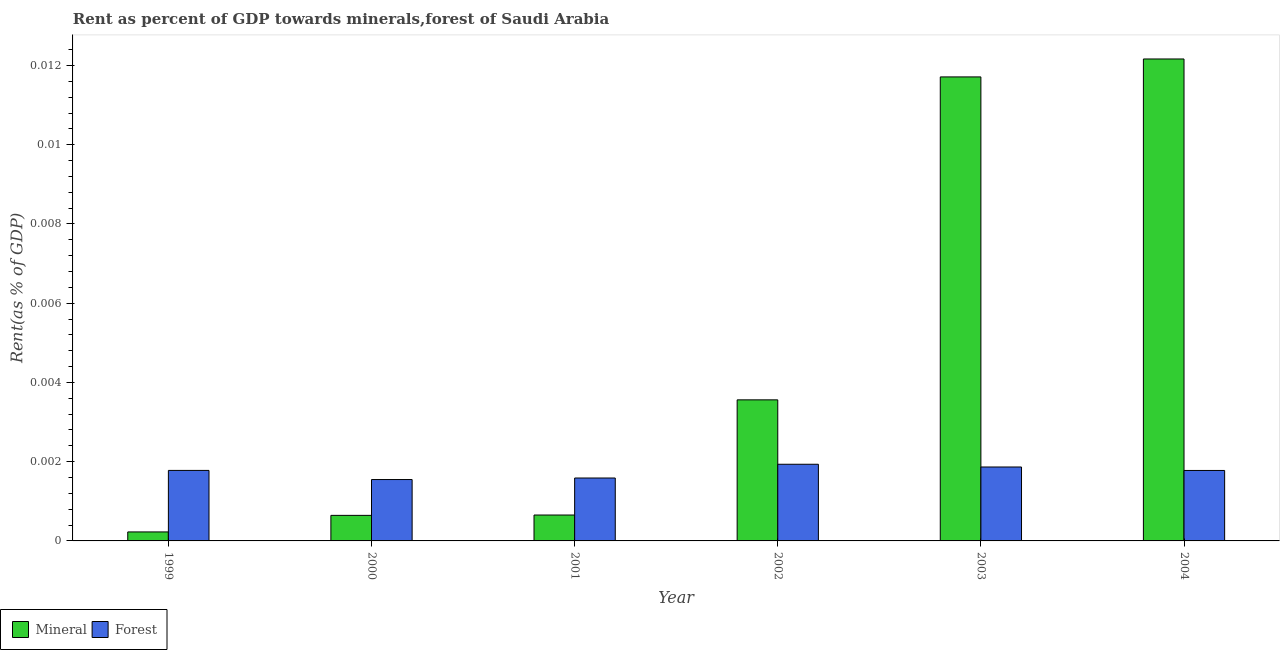How many groups of bars are there?
Provide a short and direct response. 6. Are the number of bars per tick equal to the number of legend labels?
Your response must be concise. Yes. Are the number of bars on each tick of the X-axis equal?
Give a very brief answer. Yes. How many bars are there on the 5th tick from the left?
Your answer should be compact. 2. What is the label of the 1st group of bars from the left?
Make the answer very short. 1999. What is the mineral rent in 2002?
Offer a very short reply. 0. Across all years, what is the maximum mineral rent?
Your answer should be very brief. 0.01. Across all years, what is the minimum forest rent?
Offer a terse response. 0. In which year was the mineral rent minimum?
Keep it short and to the point. 1999. What is the total forest rent in the graph?
Your answer should be very brief. 0.01. What is the difference between the mineral rent in 2002 and that in 2003?
Offer a very short reply. -0.01. What is the difference between the forest rent in 2001 and the mineral rent in 1999?
Provide a succinct answer. -0. What is the average forest rent per year?
Offer a terse response. 0. In the year 2003, what is the difference between the forest rent and mineral rent?
Make the answer very short. 0. What is the ratio of the mineral rent in 1999 to that in 2004?
Provide a succinct answer. 0.02. Is the mineral rent in 2002 less than that in 2004?
Your response must be concise. Yes. Is the difference between the mineral rent in 2000 and 2004 greater than the difference between the forest rent in 2000 and 2004?
Your answer should be very brief. No. What is the difference between the highest and the second highest mineral rent?
Your response must be concise. 0. What is the difference between the highest and the lowest forest rent?
Offer a terse response. 0. In how many years, is the mineral rent greater than the average mineral rent taken over all years?
Your answer should be compact. 2. Is the sum of the forest rent in 2002 and 2003 greater than the maximum mineral rent across all years?
Your answer should be compact. Yes. What does the 2nd bar from the left in 2001 represents?
Your answer should be very brief. Forest. What does the 2nd bar from the right in 2004 represents?
Offer a terse response. Mineral. How many years are there in the graph?
Offer a terse response. 6. What is the difference between two consecutive major ticks on the Y-axis?
Offer a terse response. 0. How many legend labels are there?
Offer a terse response. 2. What is the title of the graph?
Offer a terse response. Rent as percent of GDP towards minerals,forest of Saudi Arabia. What is the label or title of the X-axis?
Make the answer very short. Year. What is the label or title of the Y-axis?
Offer a terse response. Rent(as % of GDP). What is the Rent(as % of GDP) of Mineral in 1999?
Your answer should be very brief. 0. What is the Rent(as % of GDP) in Forest in 1999?
Ensure brevity in your answer.  0. What is the Rent(as % of GDP) in Mineral in 2000?
Offer a terse response. 0. What is the Rent(as % of GDP) in Forest in 2000?
Give a very brief answer. 0. What is the Rent(as % of GDP) of Mineral in 2001?
Offer a very short reply. 0. What is the Rent(as % of GDP) of Forest in 2001?
Your answer should be very brief. 0. What is the Rent(as % of GDP) in Mineral in 2002?
Offer a terse response. 0. What is the Rent(as % of GDP) of Forest in 2002?
Offer a very short reply. 0. What is the Rent(as % of GDP) of Mineral in 2003?
Provide a short and direct response. 0.01. What is the Rent(as % of GDP) of Forest in 2003?
Offer a terse response. 0. What is the Rent(as % of GDP) of Mineral in 2004?
Keep it short and to the point. 0.01. What is the Rent(as % of GDP) of Forest in 2004?
Offer a very short reply. 0. Across all years, what is the maximum Rent(as % of GDP) of Mineral?
Offer a very short reply. 0.01. Across all years, what is the maximum Rent(as % of GDP) of Forest?
Provide a short and direct response. 0. Across all years, what is the minimum Rent(as % of GDP) of Mineral?
Offer a terse response. 0. Across all years, what is the minimum Rent(as % of GDP) of Forest?
Give a very brief answer. 0. What is the total Rent(as % of GDP) of Mineral in the graph?
Offer a very short reply. 0.03. What is the total Rent(as % of GDP) in Forest in the graph?
Give a very brief answer. 0.01. What is the difference between the Rent(as % of GDP) of Mineral in 1999 and that in 2000?
Provide a short and direct response. -0. What is the difference between the Rent(as % of GDP) in Forest in 1999 and that in 2000?
Offer a terse response. 0. What is the difference between the Rent(as % of GDP) in Mineral in 1999 and that in 2001?
Give a very brief answer. -0. What is the difference between the Rent(as % of GDP) of Mineral in 1999 and that in 2002?
Provide a short and direct response. -0. What is the difference between the Rent(as % of GDP) of Forest in 1999 and that in 2002?
Keep it short and to the point. -0. What is the difference between the Rent(as % of GDP) in Mineral in 1999 and that in 2003?
Make the answer very short. -0.01. What is the difference between the Rent(as % of GDP) of Forest in 1999 and that in 2003?
Make the answer very short. -0. What is the difference between the Rent(as % of GDP) in Mineral in 1999 and that in 2004?
Make the answer very short. -0.01. What is the difference between the Rent(as % of GDP) in Forest in 1999 and that in 2004?
Provide a succinct answer. 0. What is the difference between the Rent(as % of GDP) in Forest in 2000 and that in 2001?
Ensure brevity in your answer.  -0. What is the difference between the Rent(as % of GDP) of Mineral in 2000 and that in 2002?
Your answer should be very brief. -0. What is the difference between the Rent(as % of GDP) of Forest in 2000 and that in 2002?
Your answer should be compact. -0. What is the difference between the Rent(as % of GDP) in Mineral in 2000 and that in 2003?
Your response must be concise. -0.01. What is the difference between the Rent(as % of GDP) of Forest in 2000 and that in 2003?
Provide a succinct answer. -0. What is the difference between the Rent(as % of GDP) in Mineral in 2000 and that in 2004?
Keep it short and to the point. -0.01. What is the difference between the Rent(as % of GDP) of Forest in 2000 and that in 2004?
Make the answer very short. -0. What is the difference between the Rent(as % of GDP) in Mineral in 2001 and that in 2002?
Provide a short and direct response. -0. What is the difference between the Rent(as % of GDP) in Forest in 2001 and that in 2002?
Offer a very short reply. -0. What is the difference between the Rent(as % of GDP) in Mineral in 2001 and that in 2003?
Give a very brief answer. -0.01. What is the difference between the Rent(as % of GDP) in Forest in 2001 and that in 2003?
Ensure brevity in your answer.  -0. What is the difference between the Rent(as % of GDP) of Mineral in 2001 and that in 2004?
Ensure brevity in your answer.  -0.01. What is the difference between the Rent(as % of GDP) of Forest in 2001 and that in 2004?
Provide a succinct answer. -0. What is the difference between the Rent(as % of GDP) of Mineral in 2002 and that in 2003?
Offer a very short reply. -0.01. What is the difference between the Rent(as % of GDP) in Forest in 2002 and that in 2003?
Keep it short and to the point. 0. What is the difference between the Rent(as % of GDP) in Mineral in 2002 and that in 2004?
Your response must be concise. -0.01. What is the difference between the Rent(as % of GDP) in Mineral in 2003 and that in 2004?
Provide a short and direct response. -0. What is the difference between the Rent(as % of GDP) in Forest in 2003 and that in 2004?
Make the answer very short. 0. What is the difference between the Rent(as % of GDP) in Mineral in 1999 and the Rent(as % of GDP) in Forest in 2000?
Provide a succinct answer. -0. What is the difference between the Rent(as % of GDP) in Mineral in 1999 and the Rent(as % of GDP) in Forest in 2001?
Offer a terse response. -0. What is the difference between the Rent(as % of GDP) of Mineral in 1999 and the Rent(as % of GDP) of Forest in 2002?
Offer a terse response. -0. What is the difference between the Rent(as % of GDP) in Mineral in 1999 and the Rent(as % of GDP) in Forest in 2003?
Your answer should be very brief. -0. What is the difference between the Rent(as % of GDP) of Mineral in 1999 and the Rent(as % of GDP) of Forest in 2004?
Make the answer very short. -0. What is the difference between the Rent(as % of GDP) of Mineral in 2000 and the Rent(as % of GDP) of Forest in 2001?
Your answer should be compact. -0. What is the difference between the Rent(as % of GDP) of Mineral in 2000 and the Rent(as % of GDP) of Forest in 2002?
Make the answer very short. -0. What is the difference between the Rent(as % of GDP) of Mineral in 2000 and the Rent(as % of GDP) of Forest in 2003?
Make the answer very short. -0. What is the difference between the Rent(as % of GDP) of Mineral in 2000 and the Rent(as % of GDP) of Forest in 2004?
Provide a short and direct response. -0. What is the difference between the Rent(as % of GDP) in Mineral in 2001 and the Rent(as % of GDP) in Forest in 2002?
Make the answer very short. -0. What is the difference between the Rent(as % of GDP) of Mineral in 2001 and the Rent(as % of GDP) of Forest in 2003?
Your response must be concise. -0. What is the difference between the Rent(as % of GDP) in Mineral in 2001 and the Rent(as % of GDP) in Forest in 2004?
Your answer should be very brief. -0. What is the difference between the Rent(as % of GDP) in Mineral in 2002 and the Rent(as % of GDP) in Forest in 2003?
Your answer should be very brief. 0. What is the difference between the Rent(as % of GDP) of Mineral in 2002 and the Rent(as % of GDP) of Forest in 2004?
Your answer should be compact. 0. What is the difference between the Rent(as % of GDP) of Mineral in 2003 and the Rent(as % of GDP) of Forest in 2004?
Provide a short and direct response. 0.01. What is the average Rent(as % of GDP) of Mineral per year?
Keep it short and to the point. 0. What is the average Rent(as % of GDP) of Forest per year?
Keep it short and to the point. 0. In the year 1999, what is the difference between the Rent(as % of GDP) of Mineral and Rent(as % of GDP) of Forest?
Offer a terse response. -0. In the year 2000, what is the difference between the Rent(as % of GDP) in Mineral and Rent(as % of GDP) in Forest?
Make the answer very short. -0. In the year 2001, what is the difference between the Rent(as % of GDP) of Mineral and Rent(as % of GDP) of Forest?
Give a very brief answer. -0. In the year 2002, what is the difference between the Rent(as % of GDP) in Mineral and Rent(as % of GDP) in Forest?
Provide a succinct answer. 0. In the year 2003, what is the difference between the Rent(as % of GDP) in Mineral and Rent(as % of GDP) in Forest?
Provide a short and direct response. 0.01. In the year 2004, what is the difference between the Rent(as % of GDP) in Mineral and Rent(as % of GDP) in Forest?
Keep it short and to the point. 0.01. What is the ratio of the Rent(as % of GDP) in Mineral in 1999 to that in 2000?
Your answer should be compact. 0.35. What is the ratio of the Rent(as % of GDP) in Forest in 1999 to that in 2000?
Make the answer very short. 1.15. What is the ratio of the Rent(as % of GDP) of Mineral in 1999 to that in 2001?
Your response must be concise. 0.35. What is the ratio of the Rent(as % of GDP) of Forest in 1999 to that in 2001?
Give a very brief answer. 1.12. What is the ratio of the Rent(as % of GDP) in Mineral in 1999 to that in 2002?
Your response must be concise. 0.06. What is the ratio of the Rent(as % of GDP) in Forest in 1999 to that in 2002?
Provide a short and direct response. 0.92. What is the ratio of the Rent(as % of GDP) in Mineral in 1999 to that in 2003?
Provide a short and direct response. 0.02. What is the ratio of the Rent(as % of GDP) of Forest in 1999 to that in 2003?
Provide a short and direct response. 0.95. What is the ratio of the Rent(as % of GDP) of Mineral in 1999 to that in 2004?
Your answer should be compact. 0.02. What is the ratio of the Rent(as % of GDP) of Forest in 1999 to that in 2004?
Your answer should be compact. 1. What is the ratio of the Rent(as % of GDP) of Mineral in 2000 to that in 2001?
Your response must be concise. 0.99. What is the ratio of the Rent(as % of GDP) of Forest in 2000 to that in 2001?
Make the answer very short. 0.98. What is the ratio of the Rent(as % of GDP) in Mineral in 2000 to that in 2002?
Keep it short and to the point. 0.18. What is the ratio of the Rent(as % of GDP) of Forest in 2000 to that in 2002?
Your response must be concise. 0.8. What is the ratio of the Rent(as % of GDP) in Mineral in 2000 to that in 2003?
Your response must be concise. 0.06. What is the ratio of the Rent(as % of GDP) in Forest in 2000 to that in 2003?
Your answer should be very brief. 0.83. What is the ratio of the Rent(as % of GDP) in Mineral in 2000 to that in 2004?
Your answer should be compact. 0.05. What is the ratio of the Rent(as % of GDP) in Forest in 2000 to that in 2004?
Give a very brief answer. 0.87. What is the ratio of the Rent(as % of GDP) in Mineral in 2001 to that in 2002?
Make the answer very short. 0.18. What is the ratio of the Rent(as % of GDP) in Forest in 2001 to that in 2002?
Your answer should be compact. 0.82. What is the ratio of the Rent(as % of GDP) in Mineral in 2001 to that in 2003?
Ensure brevity in your answer.  0.06. What is the ratio of the Rent(as % of GDP) in Forest in 2001 to that in 2003?
Your answer should be compact. 0.85. What is the ratio of the Rent(as % of GDP) of Mineral in 2001 to that in 2004?
Offer a very short reply. 0.05. What is the ratio of the Rent(as % of GDP) of Forest in 2001 to that in 2004?
Ensure brevity in your answer.  0.89. What is the ratio of the Rent(as % of GDP) in Mineral in 2002 to that in 2003?
Your answer should be compact. 0.3. What is the ratio of the Rent(as % of GDP) of Forest in 2002 to that in 2003?
Give a very brief answer. 1.04. What is the ratio of the Rent(as % of GDP) of Mineral in 2002 to that in 2004?
Make the answer very short. 0.29. What is the ratio of the Rent(as % of GDP) of Forest in 2002 to that in 2004?
Make the answer very short. 1.09. What is the ratio of the Rent(as % of GDP) in Mineral in 2003 to that in 2004?
Offer a very short reply. 0.96. What is the ratio of the Rent(as % of GDP) of Forest in 2003 to that in 2004?
Ensure brevity in your answer.  1.05. What is the difference between the highest and the second highest Rent(as % of GDP) in Mineral?
Offer a terse response. 0. What is the difference between the highest and the second highest Rent(as % of GDP) of Forest?
Ensure brevity in your answer.  0. What is the difference between the highest and the lowest Rent(as % of GDP) in Mineral?
Keep it short and to the point. 0.01. What is the difference between the highest and the lowest Rent(as % of GDP) of Forest?
Your answer should be compact. 0. 